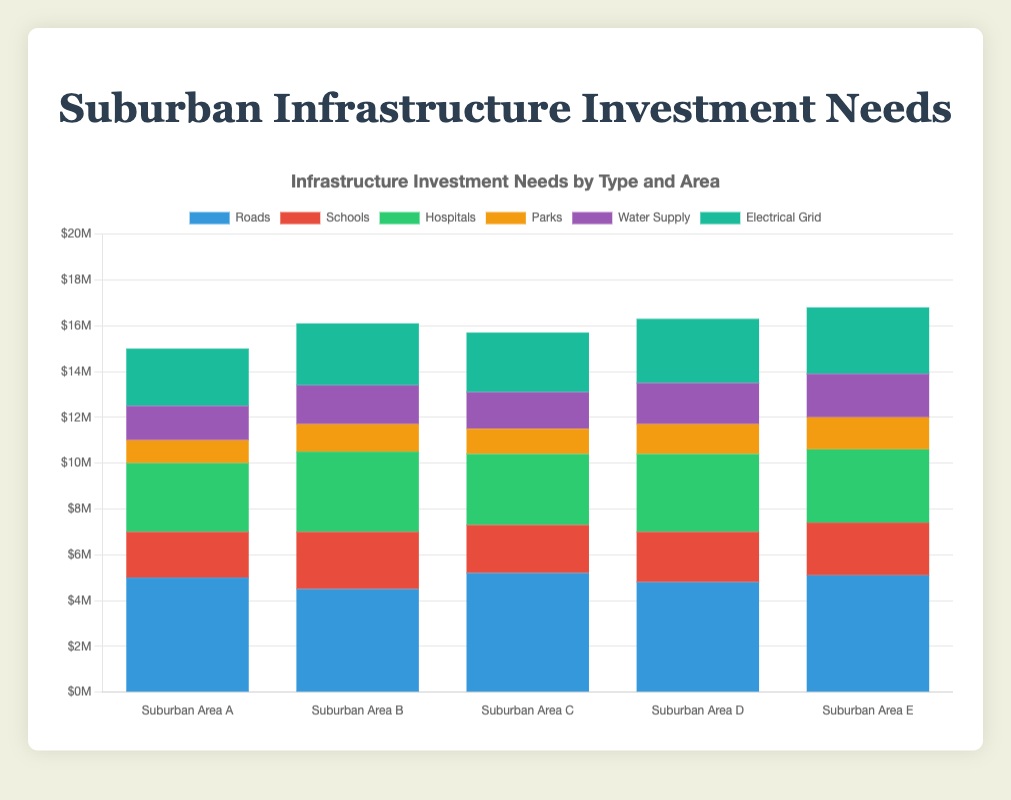Which suburban area has the highest overall infrastructure investment needs? To determine this, sum the values of all the infrastructure types for each suburban area. Suburban Area C: $5200000 + $2100000 + $3100000 + $1100000 + $1600000 + $2600000 = $15700000. Suburban Area D: $4800000 + $2200000 + $3400000 + $1300000 + $1800000 + $2800000 = $16300000. Suburban Area E: $5100000 + $2300000 + $3200000 + $1400000 + $1900000 + $2900000 = $16800000. Suburban Area E has the highest investment needs.
Answer: Suburban Area E Which type of infrastructure needs the most investment in Suburban Area B? Refer to the bars for Suburban Area B and compare their heights. The investment amounts are Roads: $4500000, Schools: $2500000, Hospitals: $3500000, Parks: $1200000, Water Supply: $1700000, Electrical Grid: $2700000. Roads have the highest investment.
Answer: Roads What is the total investment needed for hospitals across all suburban areas? Add the investments for hospitals across all areas. $3000000 (A) + $3500000 (B) + $3100000 (C) + $3400000 (D) + $3200000 (E) = $16200000.
Answer: $16200000 Which suburban area has the lowest investment need for parks? Compare the investment in parks across all areas. Suburban Area A: $1000000, B: $1200000, C: $1100000, D: $1300000, E: $1400000. Suburban Area A has the lowest investment need.
Answer: Suburban Area A Is the investment in water supply greater than the investment in electrical grid for Suburban Area D? Check the values for water supply and electrical grid in Suburban Area D. Water Supply: $1800000, Electrical Grid: $2800000. Compare the values.
Answer: No Which suburban area has the highest investment in schools? Compare the heights of the bars for schools across all areas. Suburban Area A: $2000000, B: $2500000, C: $2100000, D: $2200000, E: $2300000. Suburban Area B has the highest investment.
Answer: Suburban Area B What is the difference in total infrastructure investment needs between Suburban Area A and Suburban Area C? Calculate the total investment for each area and find the difference. Suburban Area A: $5000000 + $2000000 + $3000000 + $1000000 + $1500000 + $2500000 = $15000000. Suburban Area C: $5200000 + $2100000 + $3100000 + $1100000 + $1600000 + $2600000 = $15700000. Difference: $15700000 - $15000000 = $700000.
Answer: $700000 What is the average investment needed for roads across the suburban areas? Add the investment for roads in all areas and divide by the number of areas. ($5000000 + $4500000 + $5200000 + $4800000 + $5100000) / 5 = $4850000.
Answer: $4850000 